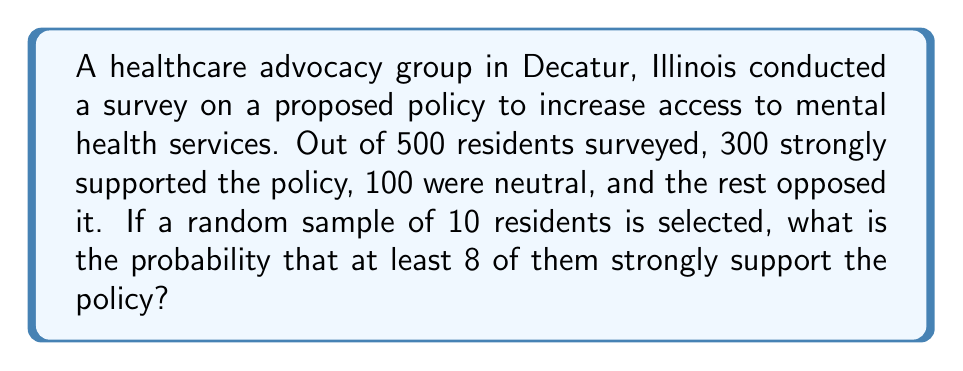Can you answer this question? Let's approach this step-by-step:

1) First, we need to calculate the probability of a single resident strongly supporting the policy:
   $p = \frac{300}{500} = 0.6$

2) The probability of a resident not strongly supporting the policy is:
   $q = 1 - p = 0.4$

3) We want at least 8 out of 10 residents to strongly support the policy. This can happen in three ways:
   - Exactly 8 out of 10
   - Exactly 9 out of 10
   - All 10 out of 10

4) We can use the binomial probability formula for each of these cases:
   $$P(X = k) = \binom{n}{k} p^k q^{n-k}$$
   where $n = 10$, $p = 0.6$, and $k = 8, 9, \text{ or } 10$

5) Calculating each probability:
   $$P(X = 8) = \binom{10}{8} (0.6)^8 (0.4)^2 = 0.1211$$
   $$P(X = 9) = \binom{10}{9} (0.6)^9 (0.4)^1 = 0.0403$$
   $$P(X = 10) = \binom{10}{10} (0.6)^{10} (0.4)^0 = 0.0060$$

6) The total probability is the sum of these individual probabilities:
   $$P(X \geq 8) = P(X = 8) + P(X = 9) + P(X = 10)$$
   $$P(X \geq 8) = 0.1211 + 0.0403 + 0.0060 = 0.1674$$

Therefore, the probability of at least 8 out of 10 randomly selected residents strongly supporting the policy is approximately 0.1674 or 16.74%.
Answer: 0.1674 